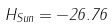<formula> <loc_0><loc_0><loc_500><loc_500>H _ { S u n } = - 2 6 . 7 6</formula> 